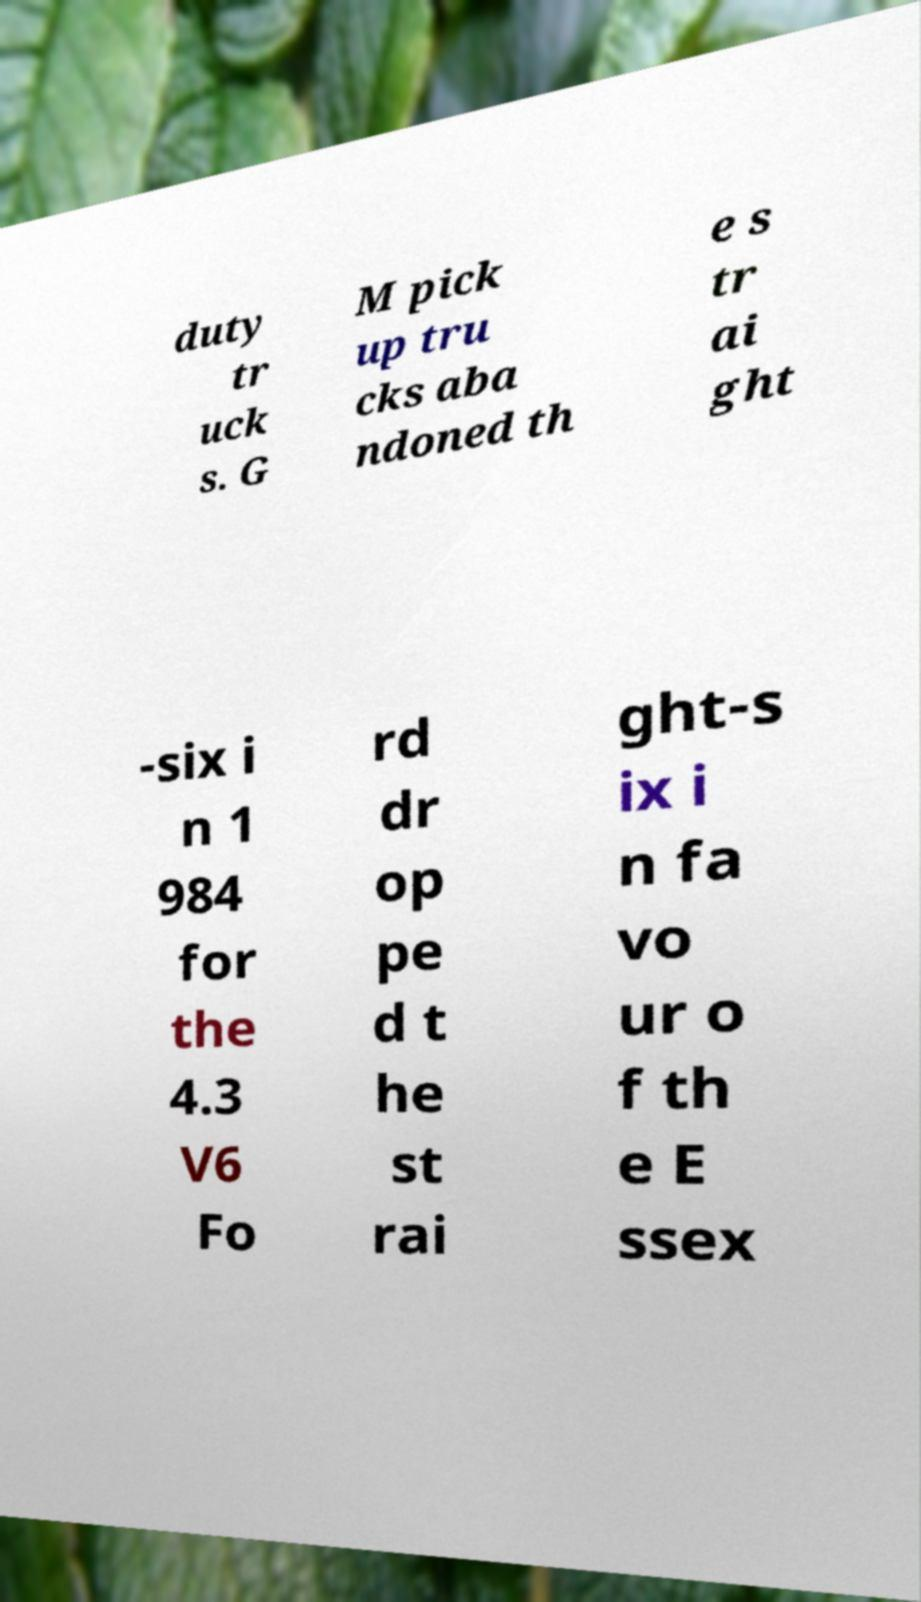Please read and relay the text visible in this image. What does it say? duty tr uck s. G M pick up tru cks aba ndoned th e s tr ai ght -six i n 1 984 for the 4.3 V6 Fo rd dr op pe d t he st rai ght-s ix i n fa vo ur o f th e E ssex 